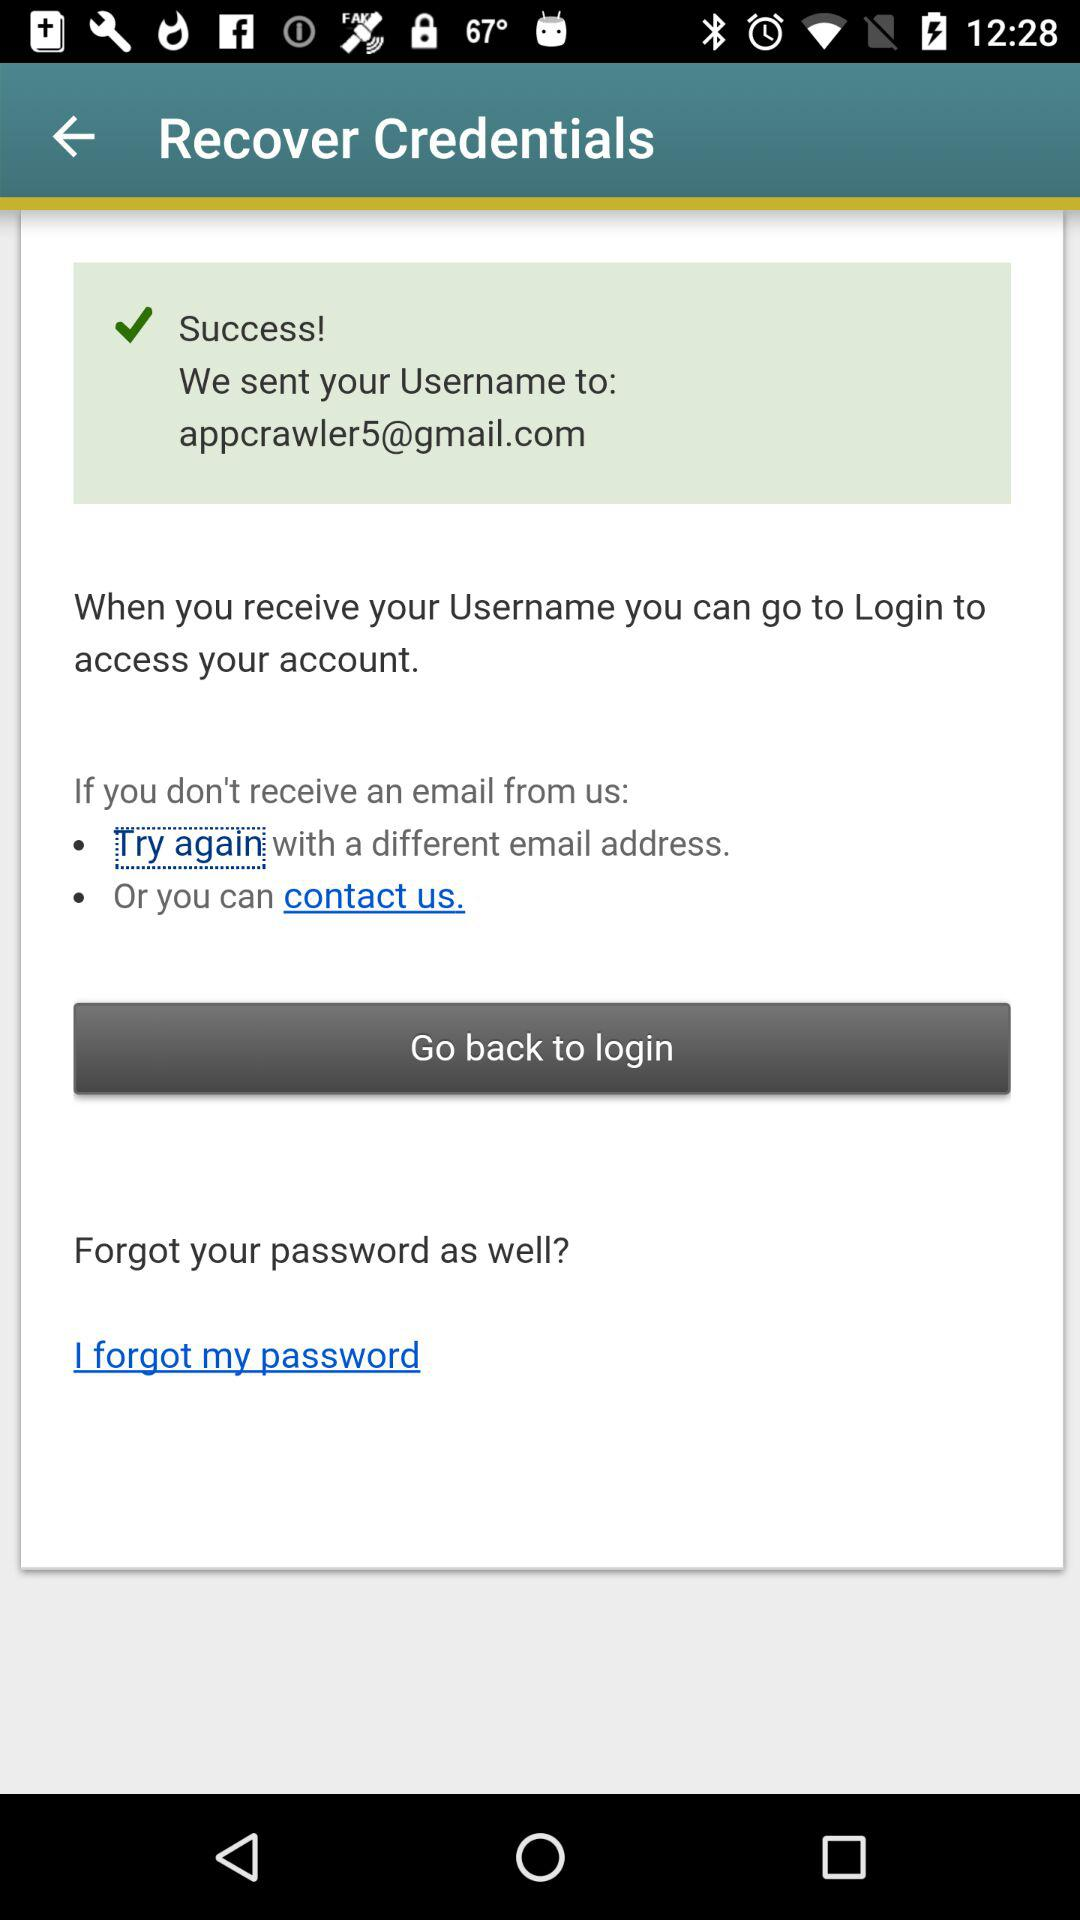How many options are available if I don't receive an email from you?
Answer the question using a single word or phrase. 2 